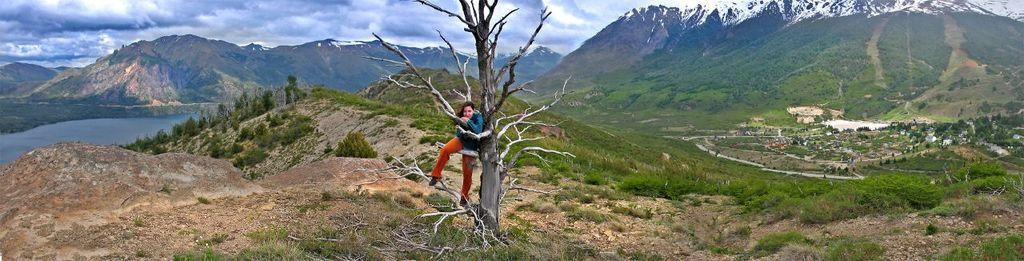What is the woman in the image doing? The woman is standing on a tree branch in the image. What can be seen in the background of the image? Mountains, water, trees, and the sky are visible in the background of the image. What is the condition of the sky in the image? Clouds are present in the sky in the image. What type of juice is the woman holding in the image? There is no juice present in the image; the woman is standing on a tree branch. 